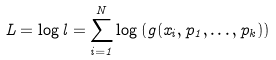Convert formula to latex. <formula><loc_0><loc_0><loc_500><loc_500>L = \log l = \sum _ { i = 1 } ^ { N } \log \left ( g ( x _ { i } , p _ { 1 } , \dots , p _ { k } ) \right )</formula> 